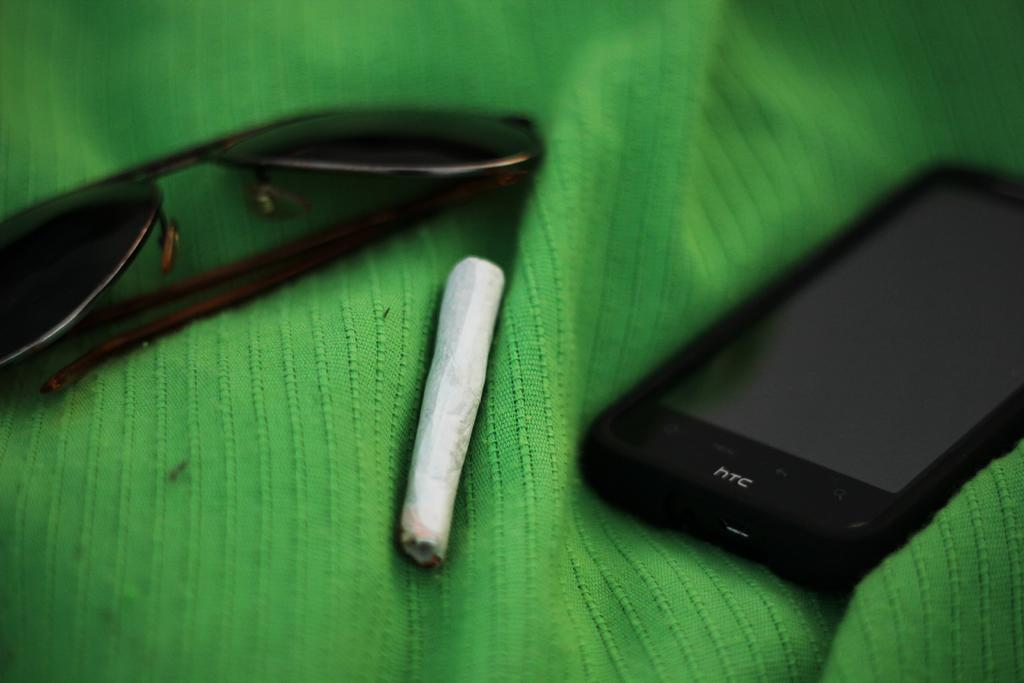<image>
Provide a brief description of the given image. An HTC brand phone is laying on a green cloth next to a cigarette and a pair of sunglasses. 